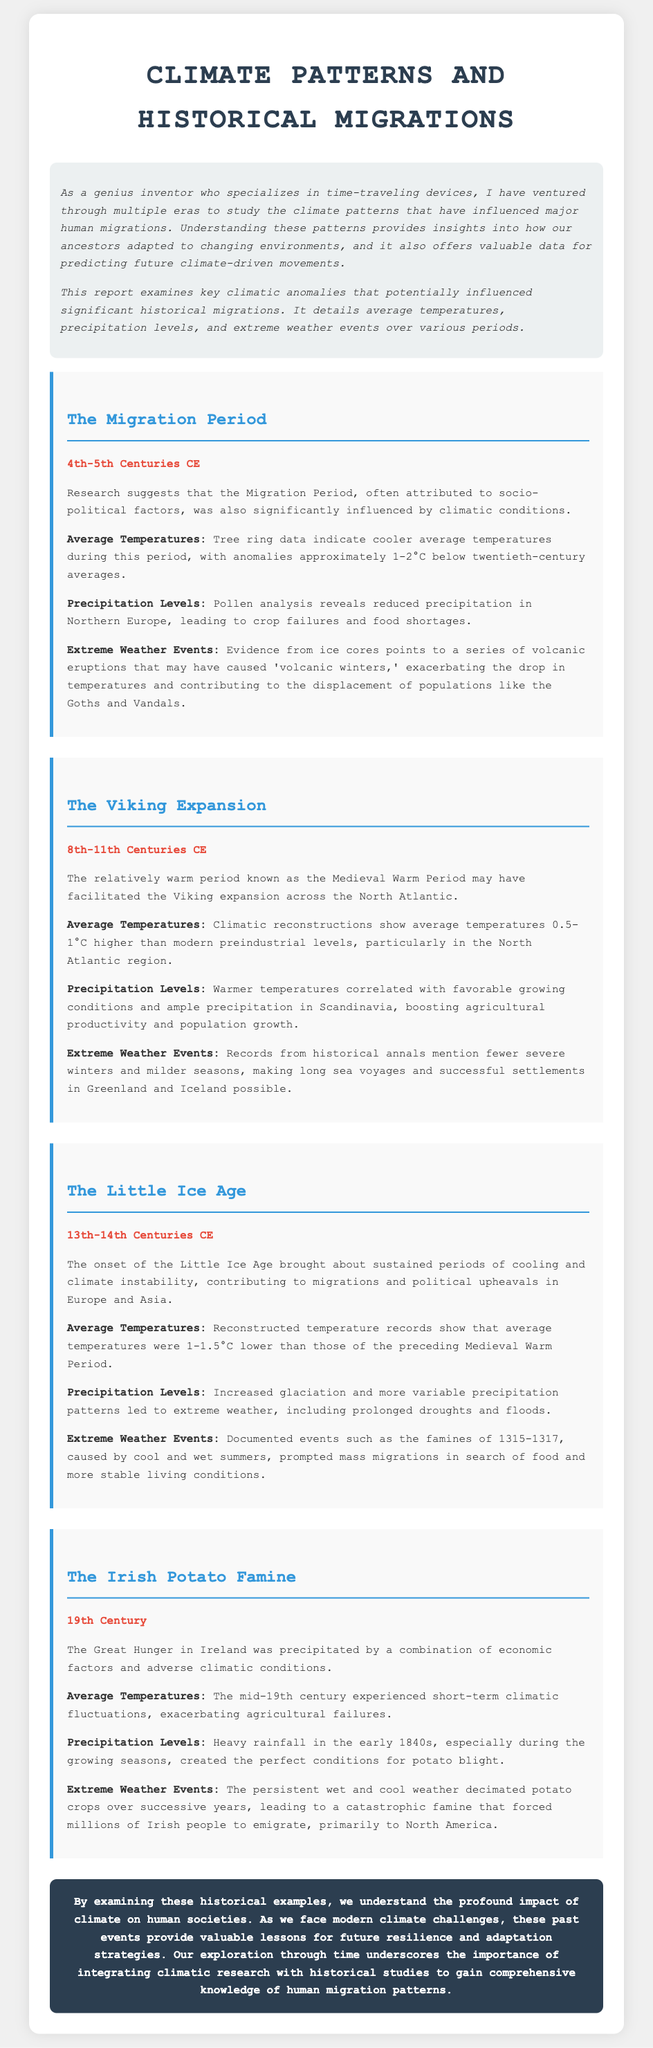what period does the Migration Period cover? The document states that the Migration Period spans the 4th to 5th centuries CE.
Answer: 4th-5th Centuries CE what average temperature anomaly is noted during the Migration Period? According to the report, the average temperatures during the Migration Period were approximately 1-2°C below twentieth-century averages.
Answer: 1-2°C below what climatic period facilitated the Viking expansion? The report indicates that the Viking expansion was facilitated by the Medieval Warm Period.
Answer: Medieval Warm Period what were the precipitation levels like during the Little Ice Age? The document mentions that during the Little Ice Age, there were increased glaciation and more variable precipitation patterns.
Answer: Variable precipitation patterns how much lower were average temperatures during the Little Ice Age compared to the preceding period? The report states that average temperatures during the Little Ice Age were 1-1.5°C lower than those of the Medieval Warm Period.
Answer: 1-1.5°C lower when did the Irish Potato Famine occur? The document notes that the Irish Potato Famine took place in the 19th century.
Answer: 19th Century what weather conditions contributed to the Great Hunger in Ireland? The document highlights that heavy rainfall during the early 1840s created conditions for potato blight.
Answer: Heavy rainfall what migratory outcome resulted from the Irish Potato Famine? The report states that the famine forced millions of Irish people to emigrate, primarily to North America.
Answer: Emigrate to North America what is the main purpose of this climate patterns report? The introductory paragraph outlines that the report seeks to examine climatic anomalies influencing historical migrations.
Answer: Examine climatic anomalies influencing historical migrations 